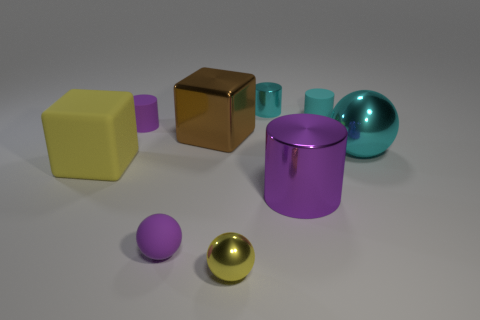What is the shape of the big metallic thing that is on the right side of the tiny yellow metal object and left of the large cyan shiny object?
Keep it short and to the point. Cylinder. Are there the same number of small yellow spheres to the left of the yellow cube and tiny cyan shiny cylinders that are in front of the large purple cylinder?
Your answer should be very brief. Yes. What number of spheres are either large things or small purple rubber things?
Provide a short and direct response. 2. What number of other big purple cylinders have the same material as the big cylinder?
Offer a terse response. 0. The rubber thing that is the same color as the big sphere is what shape?
Make the answer very short. Cylinder. There is a sphere that is on the left side of the small cyan metallic thing and behind the tiny yellow metal ball; what is it made of?
Provide a succinct answer. Rubber. There is a small rubber object that is in front of the brown metal block; what is its shape?
Give a very brief answer. Sphere. What shape is the cyan metal object that is on the right side of the purple cylinder right of the tiny yellow shiny thing?
Provide a short and direct response. Sphere. Is there a big yellow thing that has the same shape as the big purple metallic thing?
Provide a succinct answer. No. There is a brown shiny thing that is the same size as the matte cube; what is its shape?
Your answer should be compact. Cube. 